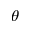Convert formula to latex. <formula><loc_0><loc_0><loc_500><loc_500>\theta</formula> 